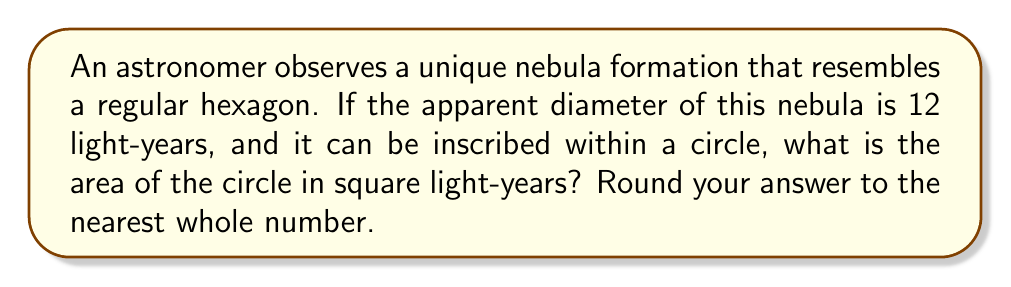Solve this math problem. Let's approach this step-by-step:

1) First, we need to recall that a regular hexagon can be divided into six equilateral triangles.

2) The diameter of the circle is equal to the distance between two opposite vertices of the hexagon, which is also the longest diagonal of the hexagon. This diameter is given as 12 light-years.

3) In a regular hexagon, this longest diagonal is equal to twice the length of one side. So, if we call the side length $s$, we have:

   $2s = 12$
   $s = 6$ light-years

4) Now, we need to find the radius of the circle. The radius is the distance from the center to any vertex of the hexagon. This forms a right triangle with half of one of the hexagon's sides.

5) If we draw this right triangle, we have:
   - The hypotenuse is the radius $r$
   - One leg is half of the hexagon's side: $s/2 = 3$ light-years
   - The other leg is the height of one of the equilateral triangles that make up the hexagon

6) The height of an equilateral triangle with side $s$ is:

   $h = \frac{\sqrt{3}}{2}s = \frac{\sqrt{3}}{2} * 6 = 3\sqrt{3}$ light-years

7) Now we can use the Pythagorean theorem to find the radius:

   $r^2 = 3^2 + (3\sqrt{3})^2 = 9 + 27 = 36$
   $r = 6$ light-years

8) The area of a circle is given by the formula $A = \pi r^2$. So:

   $A = \pi * 6^2 = 36\pi$ square light-years

9) Rounding to the nearest whole number:

   $36\pi \approx 113$ square light-years
Answer: 113 square light-years 